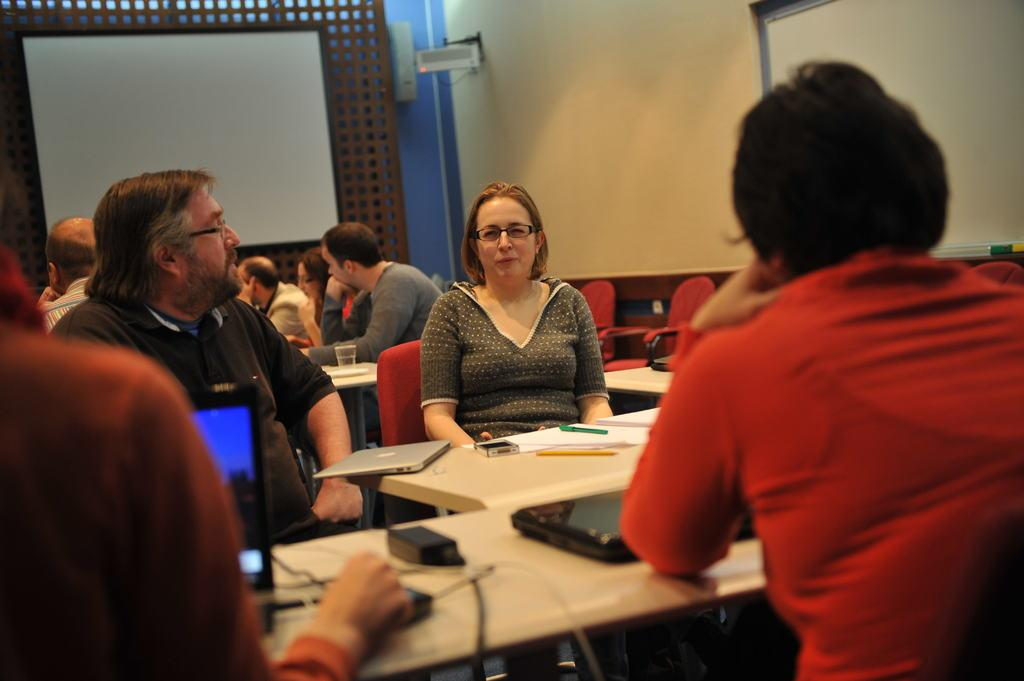What are the people in the image doing? The people in the image are seated on chairs. What is one person specifically doing in the image? There is a person operating a laptop in the image. What items can be seen on the table in the image? There are books and a laptop on the table in the image. What is the purpose of the projector screen in the image? The projector screen is visible in the image, which suggests that it might be used for presentations or displays. How much profit can be seen in the image? There is no mention of profit in the image, as it features people seated with books, a laptop, and a projector screen. What type of pin is being used by the person operating the laptop in the image? There is no pin visible in the image, and the person operating the laptop is not using one. 